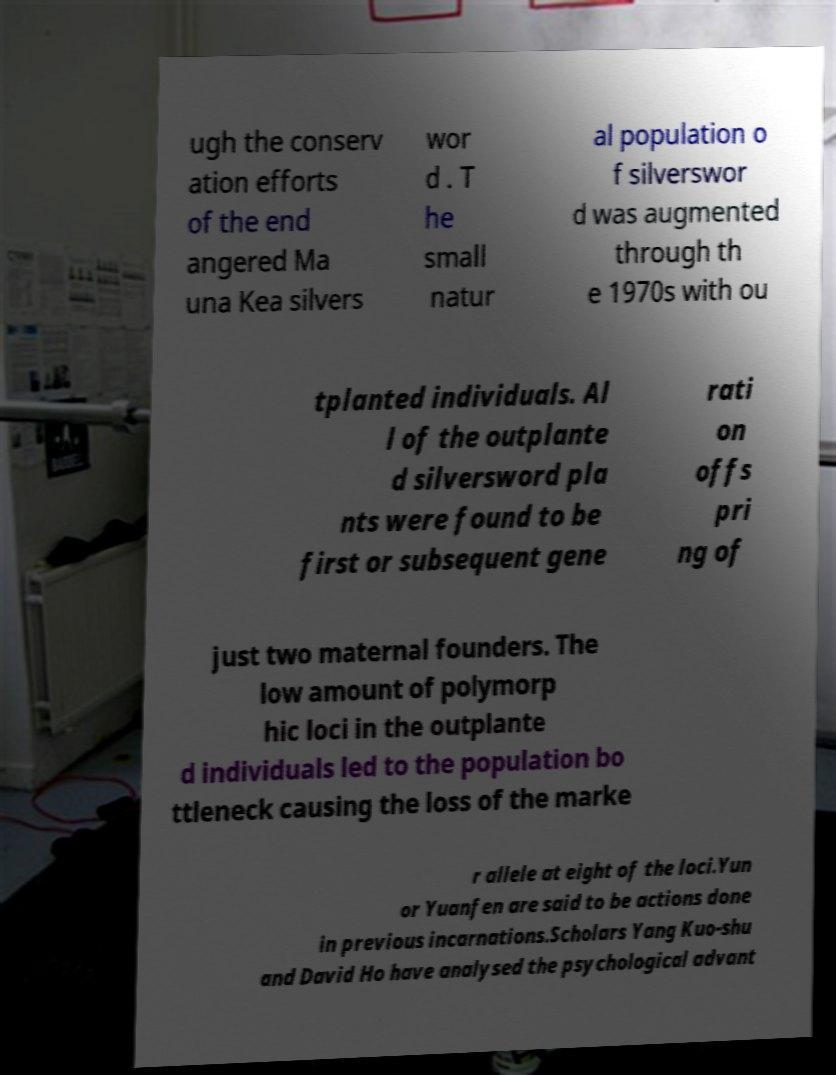Can you read and provide the text displayed in the image?This photo seems to have some interesting text. Can you extract and type it out for me? ugh the conserv ation efforts of the end angered Ma una Kea silvers wor d . T he small natur al population o f silverswor d was augmented through th e 1970s with ou tplanted individuals. Al l of the outplante d silversword pla nts were found to be first or subsequent gene rati on offs pri ng of just two maternal founders. The low amount of polymorp hic loci in the outplante d individuals led to the population bo ttleneck causing the loss of the marke r allele at eight of the loci.Yun or Yuanfen are said to be actions done in previous incarnations.Scholars Yang Kuo-shu and David Ho have analysed the psychological advant 